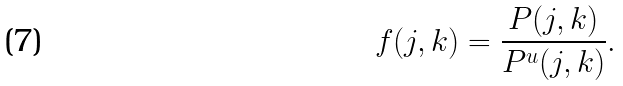Convert formula to latex. <formula><loc_0><loc_0><loc_500><loc_500>f ( j , k ) = \frac { P ( j , k ) } { P ^ { u } ( j , k ) } .</formula> 